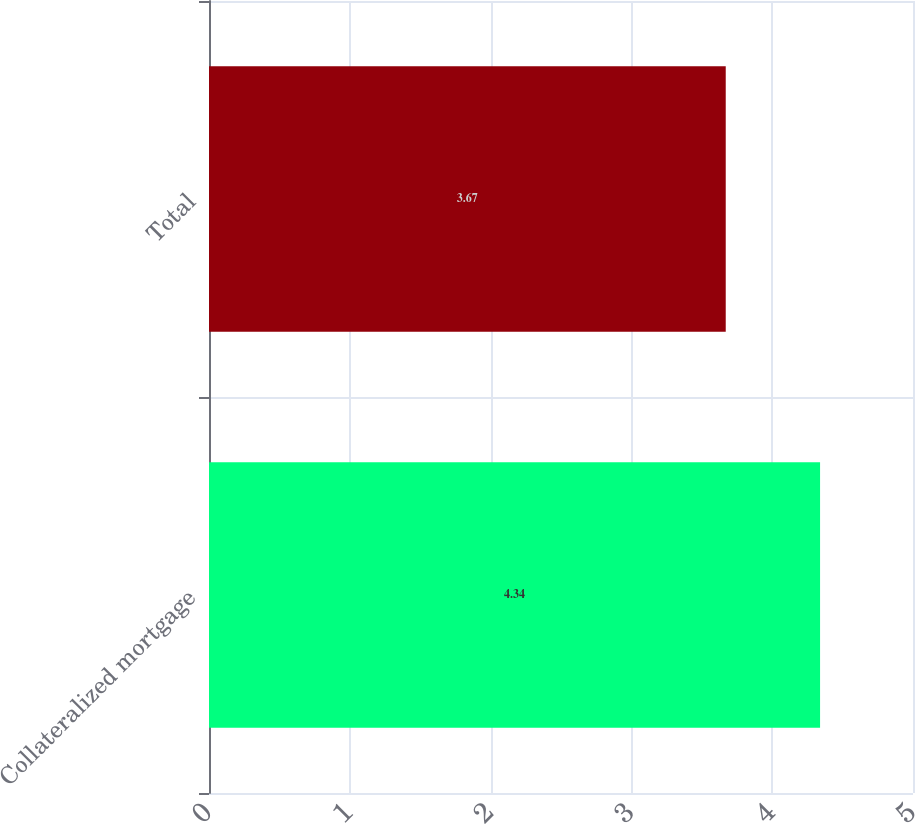Convert chart. <chart><loc_0><loc_0><loc_500><loc_500><bar_chart><fcel>Collateralized mortgage<fcel>Total<nl><fcel>4.34<fcel>3.67<nl></chart> 